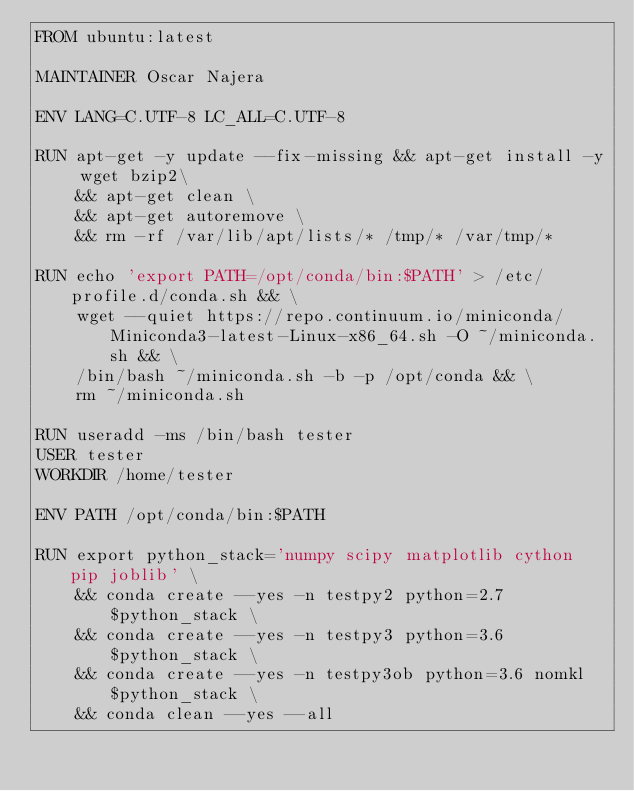Convert code to text. <code><loc_0><loc_0><loc_500><loc_500><_Dockerfile_>FROM ubuntu:latest

MAINTAINER Oscar Najera

ENV LANG=C.UTF-8 LC_ALL=C.UTF-8

RUN apt-get -y update --fix-missing && apt-get install -y wget bzip2\
    && apt-get clean \
    && apt-get autoremove \
    && rm -rf /var/lib/apt/lists/* /tmp/* /var/tmp/*

RUN echo 'export PATH=/opt/conda/bin:$PATH' > /etc/profile.d/conda.sh && \
    wget --quiet https://repo.continuum.io/miniconda/Miniconda3-latest-Linux-x86_64.sh -O ~/miniconda.sh && \
    /bin/bash ~/miniconda.sh -b -p /opt/conda && \
    rm ~/miniconda.sh

RUN useradd -ms /bin/bash tester
USER tester
WORKDIR /home/tester

ENV PATH /opt/conda/bin:$PATH

RUN export python_stack='numpy scipy matplotlib cython pip joblib' \
    && conda create --yes -n testpy2 python=2.7 $python_stack \
    && conda create --yes -n testpy3 python=3.6 $python_stack \
    && conda create --yes -n testpy3ob python=3.6 nomkl $python_stack \
    && conda clean --yes --all
</code> 